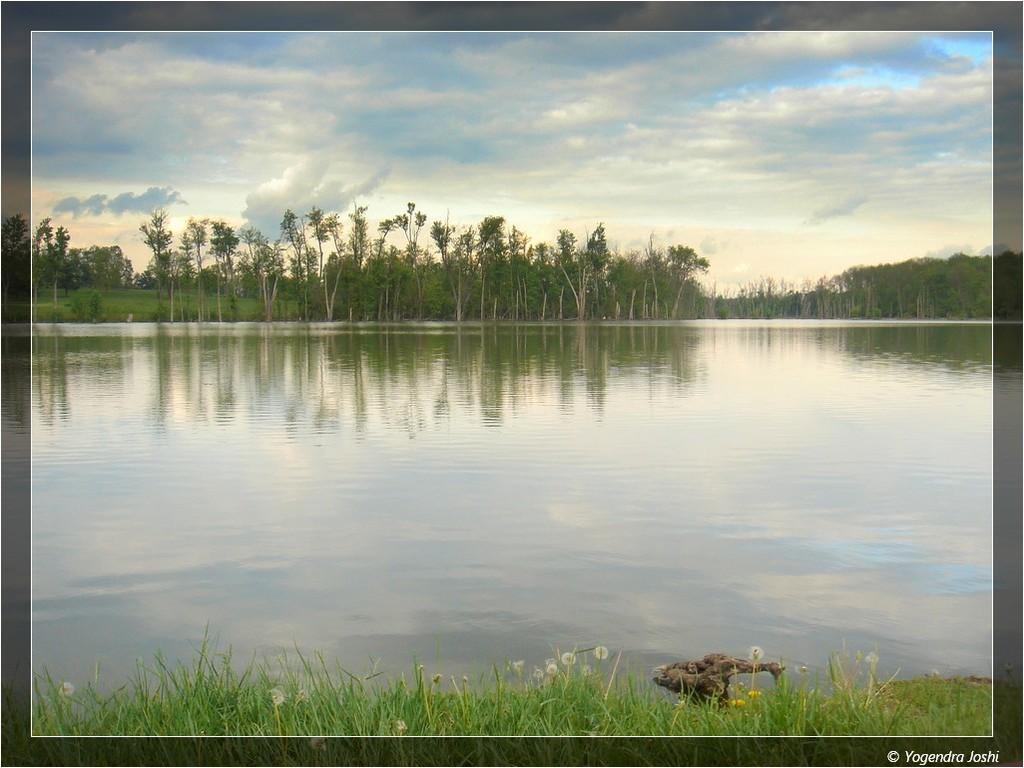Describe this image in one or two sentences. In this picture we can see the grass, water, trees and in the background we can see the sky with clouds. 